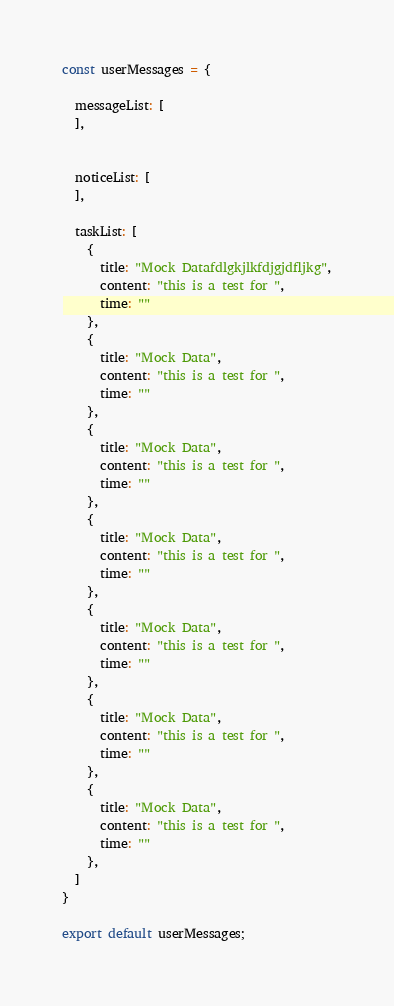Convert code to text. <code><loc_0><loc_0><loc_500><loc_500><_JavaScript_>const userMessages = {

  messageList: [
  ],


  noticeList: [
  ],

  taskList: [
    {
      title: "Mock Datafdlgkjlkfdjgjdfljkg",
      content: "this is a test for ",
      time: ""
    },
    {
      title: "Mock Data",
      content: "this is a test for ",
      time: ""
    },
    {
      title: "Mock Data",
      content: "this is a test for ",
      time: ""
    },
    {
      title: "Mock Data",
      content: "this is a test for ",
      time: ""
    },
    {
      title: "Mock Data",
      content: "this is a test for ",
      time: ""
    },
    {
      title: "Mock Data",
      content: "this is a test for ",
      time: ""
    },
    {
      title: "Mock Data",
      content: "this is a test for ",
      time: ""
    },
  ]
}

export default userMessages;</code> 